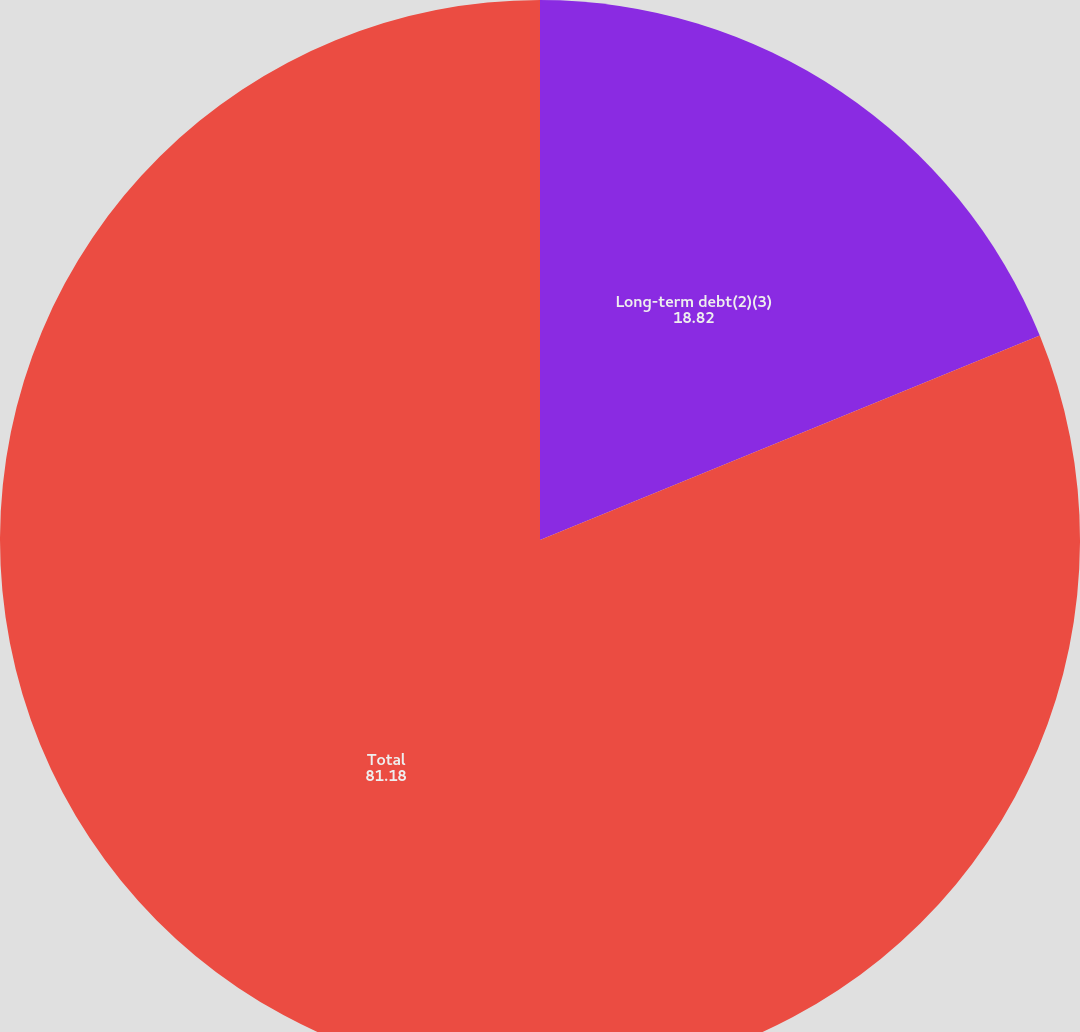<chart> <loc_0><loc_0><loc_500><loc_500><pie_chart><fcel>Long-term debt(2)(3)<fcel>Total<nl><fcel>18.82%<fcel>81.18%<nl></chart> 